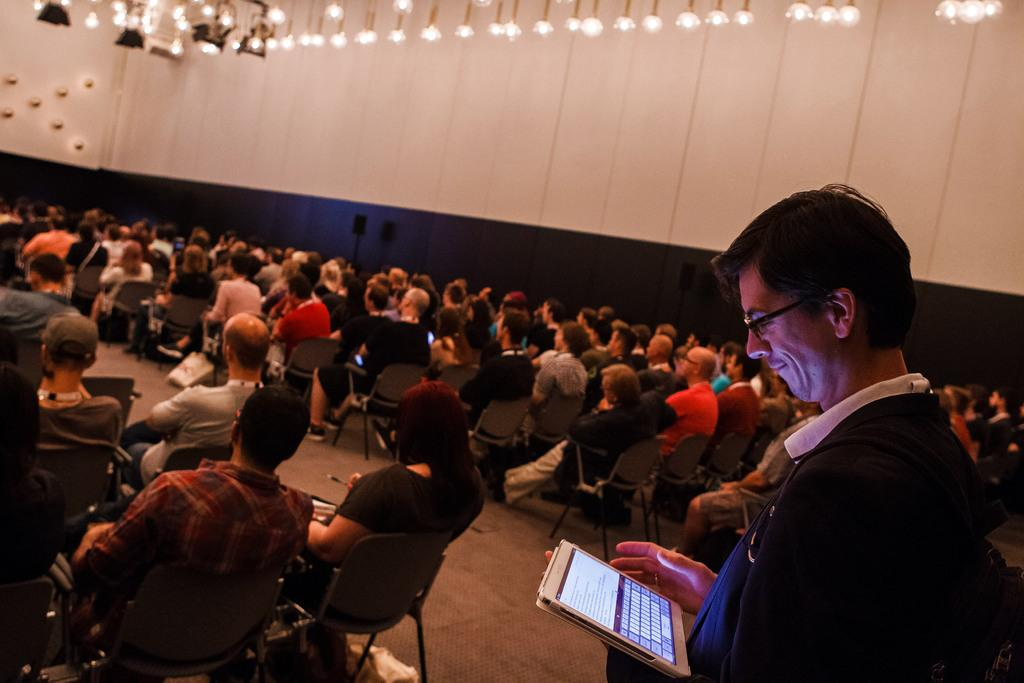What are the people in the image doing? The people in the image are sitting on chairs. What is the man in the image doing? The man in the image is standing and holding an iPad in his hand. What can be seen in the background of the image? There are lightings visible in the image. What side of the story is the man telling in the image? There is no indication in the image that the man is telling a story, so it cannot be determined from the picture. 